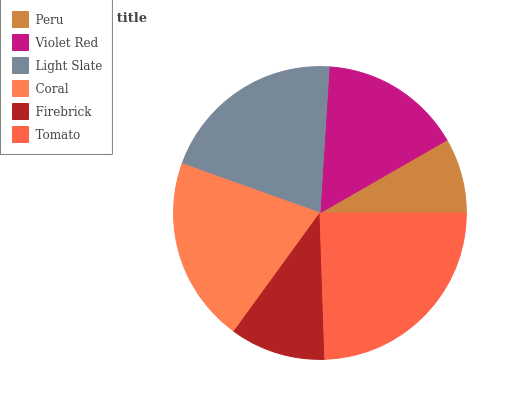Is Peru the minimum?
Answer yes or no. Yes. Is Tomato the maximum?
Answer yes or no. Yes. Is Violet Red the minimum?
Answer yes or no. No. Is Violet Red the maximum?
Answer yes or no. No. Is Violet Red greater than Peru?
Answer yes or no. Yes. Is Peru less than Violet Red?
Answer yes or no. Yes. Is Peru greater than Violet Red?
Answer yes or no. No. Is Violet Red less than Peru?
Answer yes or no. No. Is Coral the high median?
Answer yes or no. Yes. Is Violet Red the low median?
Answer yes or no. Yes. Is Tomato the high median?
Answer yes or no. No. Is Peru the low median?
Answer yes or no. No. 